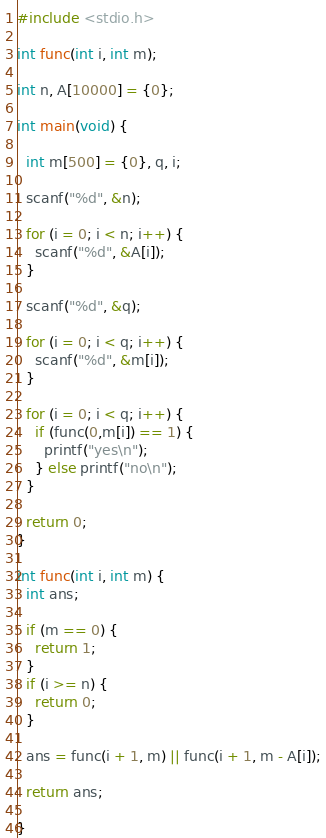<code> <loc_0><loc_0><loc_500><loc_500><_C_>#include <stdio.h>

int func(int i, int m);

int n, A[10000] = {0};

int main(void) {
  
  int m[500] = {0}, q, i;
  
  scanf("%d", &n);
  
  for (i = 0; i < n; i++) {
    scanf("%d", &A[i]);
  }
  
  scanf("%d", &q);
  
  for (i = 0; i < q; i++) {
    scanf("%d", &m[i]);
  }
  
  for (i = 0; i < q; i++) {
    if (func(0,m[i]) == 1) {
      printf("yes\n");
    } else printf("no\n");
  }
  
  return 0;
}

int func(int i, int m) {
  int ans;
  
  if (m == 0) {
    return 1;
  }
  if (i >= n) {
    return 0;
  }
  
  ans = func(i + 1, m) || func(i + 1, m - A[i]);
  
  return ans;
  
}</code> 